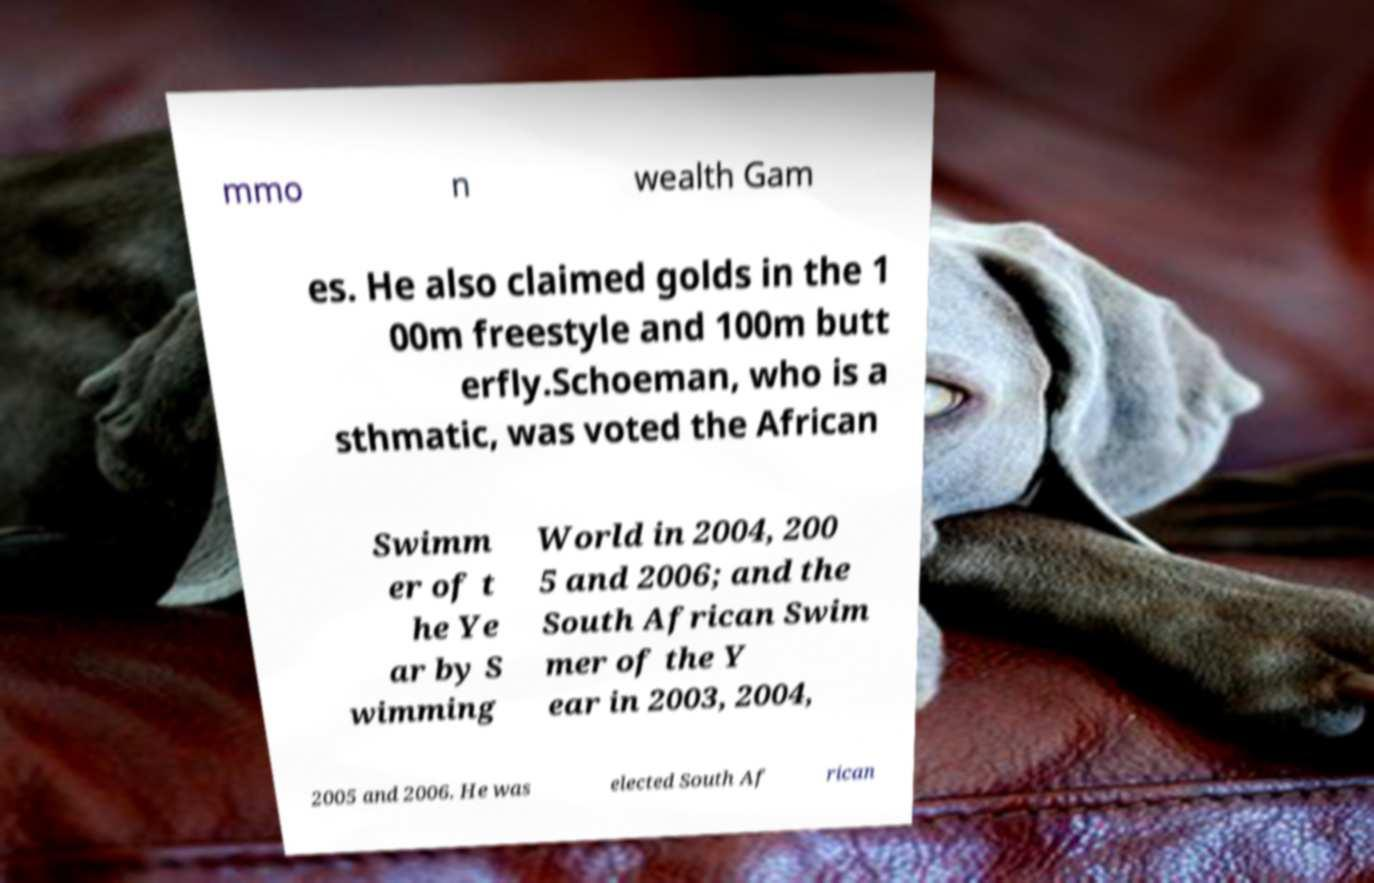Could you assist in decoding the text presented in this image and type it out clearly? mmo n wealth Gam es. He also claimed golds in the 1 00m freestyle and 100m butt erfly.Schoeman, who is a sthmatic, was voted the African Swimm er of t he Ye ar by S wimming World in 2004, 200 5 and 2006; and the South African Swim mer of the Y ear in 2003, 2004, 2005 and 2006. He was elected South Af rican 